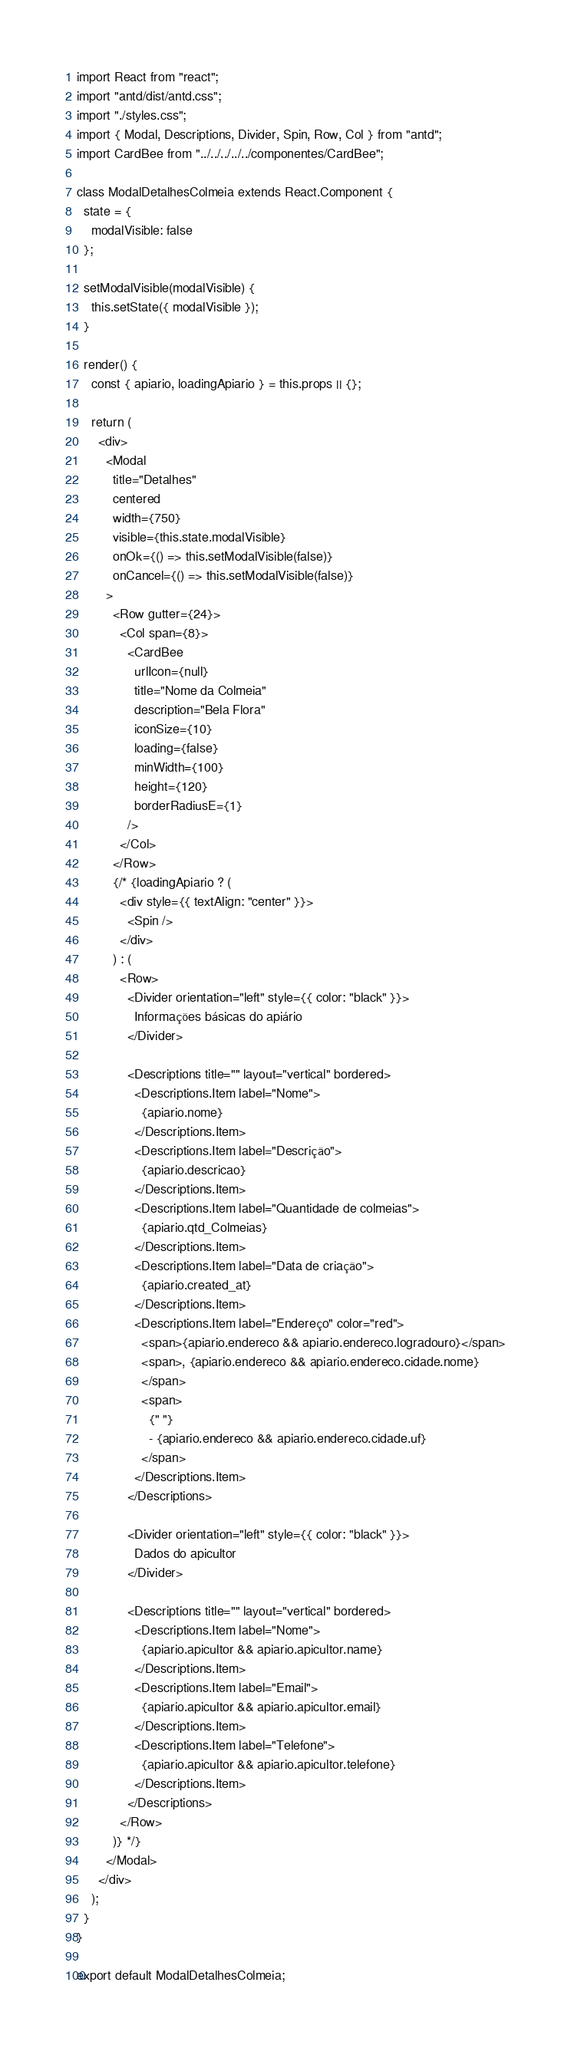<code> <loc_0><loc_0><loc_500><loc_500><_JavaScript_>import React from "react";
import "antd/dist/antd.css";
import "./styles.css";
import { Modal, Descriptions, Divider, Spin, Row, Col } from "antd";
import CardBee from "../../../../../componentes/CardBee";

class ModalDetalhesColmeia extends React.Component {
  state = {
    modalVisible: false
  };

  setModalVisible(modalVisible) {
    this.setState({ modalVisible });
  }

  render() {
    const { apiario, loadingApiario } = this.props || {};

    return (
      <div>
        <Modal
          title="Detalhes"
          centered
          width={750}
          visible={this.state.modalVisible}
          onOk={() => this.setModalVisible(false)}
          onCancel={() => this.setModalVisible(false)}
        >
          <Row gutter={24}>
            <Col span={8}>
              <CardBee
                urlIcon={null}
                title="Nome da Colmeia"
                description="Bela Flora"
                iconSize={10}
                loading={false}
                minWidth={100}
                height={120}
                borderRadiusE={1}
              />
            </Col>
          </Row>
          {/* {loadingApiario ? (
            <div style={{ textAlign: "center" }}>
              <Spin />
            </div>
          ) : (
            <Row>
              <Divider orientation="left" style={{ color: "black" }}>
                Informações básicas do apiário
              </Divider>

              <Descriptions title="" layout="vertical" bordered>
                <Descriptions.Item label="Nome">
                  {apiario.nome}
                </Descriptions.Item>
                <Descriptions.Item label="Descrição">
                  {apiario.descricao}
                </Descriptions.Item>
                <Descriptions.Item label="Quantidade de colmeias">
                  {apiario.qtd_Colmeias}
                </Descriptions.Item>
                <Descriptions.Item label="Data de criação">
                  {apiario.created_at}
                </Descriptions.Item>
                <Descriptions.Item label="Endereço" color="red">
                  <span>{apiario.endereco && apiario.endereco.logradouro}</span>
                  <span>, {apiario.endereco && apiario.endereco.cidade.nome}
                  </span>
                  <span>
                    {" "}
                    - {apiario.endereco && apiario.endereco.cidade.uf}
                  </span>
                </Descriptions.Item>
              </Descriptions>

              <Divider orientation="left" style={{ color: "black" }}>
                Dados do apicultor
              </Divider>

              <Descriptions title="" layout="vertical" bordered>
                <Descriptions.Item label="Nome">
                  {apiario.apicultor && apiario.apicultor.name}
                </Descriptions.Item>
                <Descriptions.Item label="Email">
                  {apiario.apicultor && apiario.apicultor.email}
                </Descriptions.Item>
                <Descriptions.Item label="Telefone">
                  {apiario.apicultor && apiario.apicultor.telefone}
                </Descriptions.Item>
              </Descriptions>
            </Row>
          )} */}
        </Modal>
      </div>
    );
  }
}

export default ModalDetalhesColmeia;
</code> 